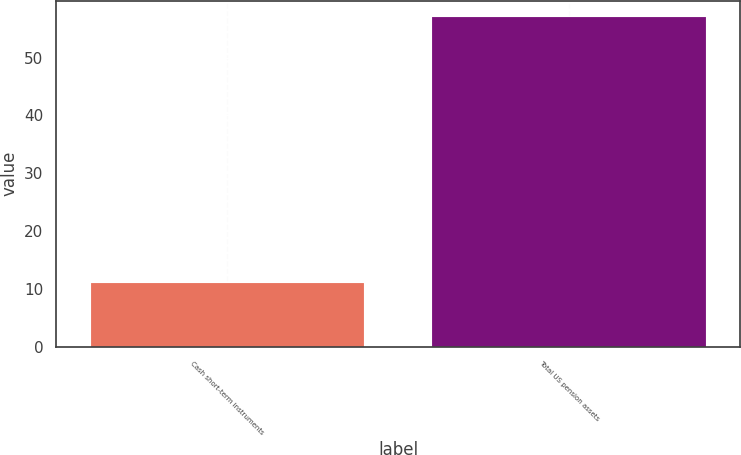<chart> <loc_0><loc_0><loc_500><loc_500><bar_chart><fcel>Cash short-term instruments<fcel>Total US pension assets<nl><fcel>11<fcel>57<nl></chart> 